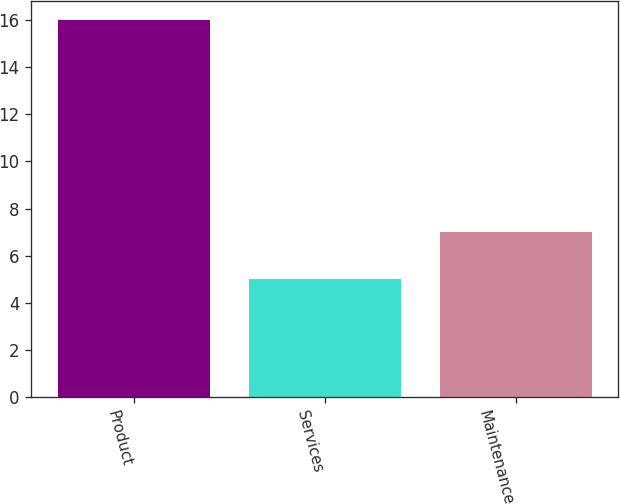<chart> <loc_0><loc_0><loc_500><loc_500><bar_chart><fcel>Product<fcel>Services<fcel>Maintenance<nl><fcel>16<fcel>5<fcel>7<nl></chart> 